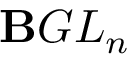<formula> <loc_0><loc_0><loc_500><loc_500>B G L _ { n }</formula> 